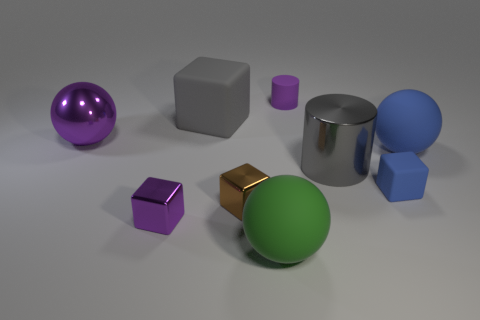Do the tiny purple rubber thing and the purple object in front of the large purple metallic thing have the same shape?
Offer a terse response. No. What material is the object that is the same color as the metallic cylinder?
Offer a very short reply. Rubber. Are there any other things that have the same shape as the big green matte thing?
Your answer should be very brief. Yes. Does the large green object have the same material as the small purple object in front of the blue rubber block?
Make the answer very short. No. What color is the thing that is behind the rubber block to the left of the small purple object that is behind the large shiny ball?
Your answer should be very brief. Purple. Are there any other things that are the same size as the blue ball?
Offer a terse response. Yes. There is a large metallic sphere; is its color the same as the small object that is behind the large gray block?
Provide a succinct answer. Yes. The small matte block has what color?
Offer a very short reply. Blue. What shape is the metallic object that is to the right of the big rubber object that is in front of the cube that is right of the small matte cylinder?
Make the answer very short. Cylinder. How many other objects are there of the same color as the large metallic cylinder?
Keep it short and to the point. 1. 